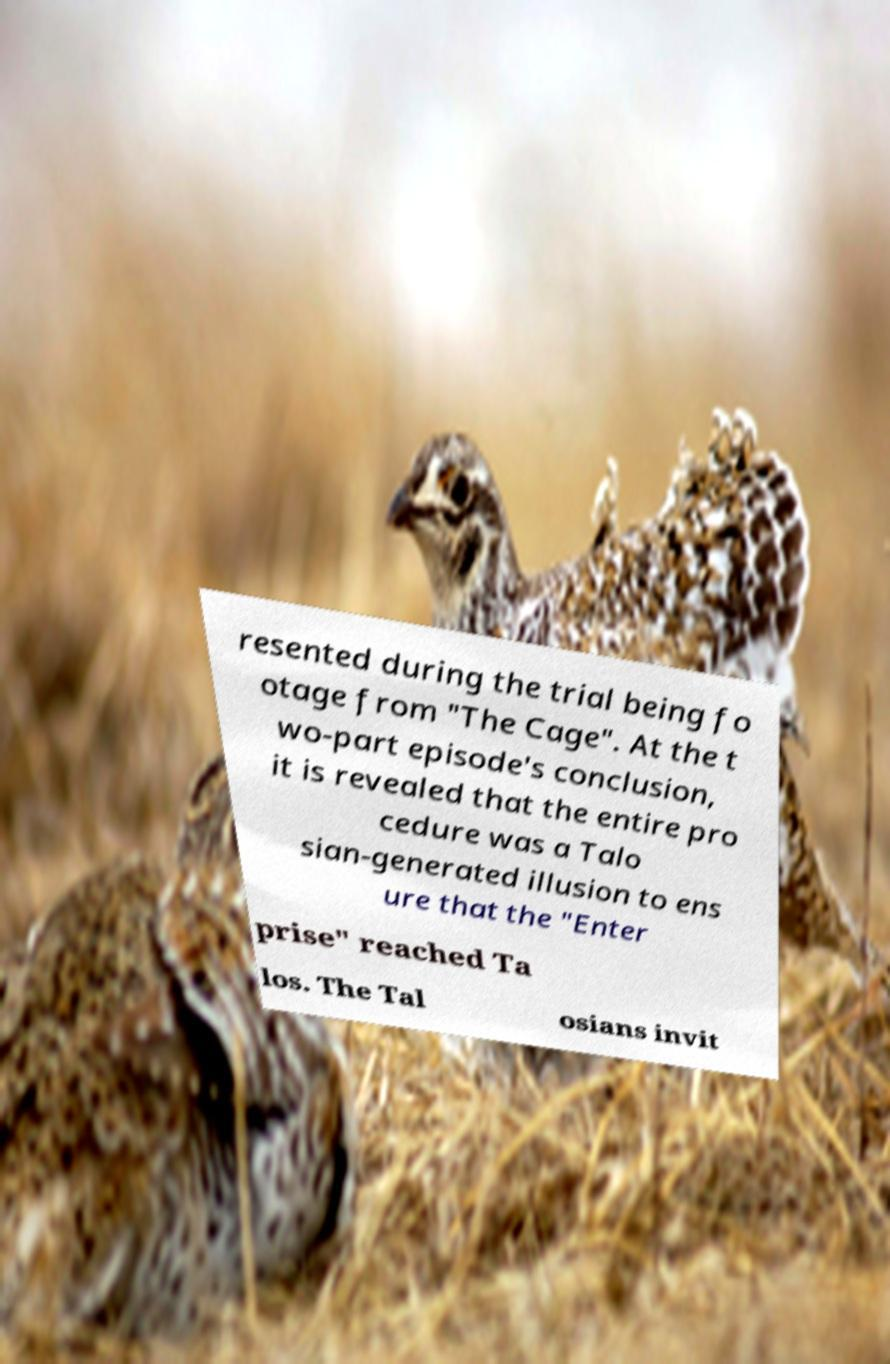There's text embedded in this image that I need extracted. Can you transcribe it verbatim? resented during the trial being fo otage from "The Cage". At the t wo-part episode's conclusion, it is revealed that the entire pro cedure was a Talo sian-generated illusion to ens ure that the "Enter prise" reached Ta los. The Tal osians invit 